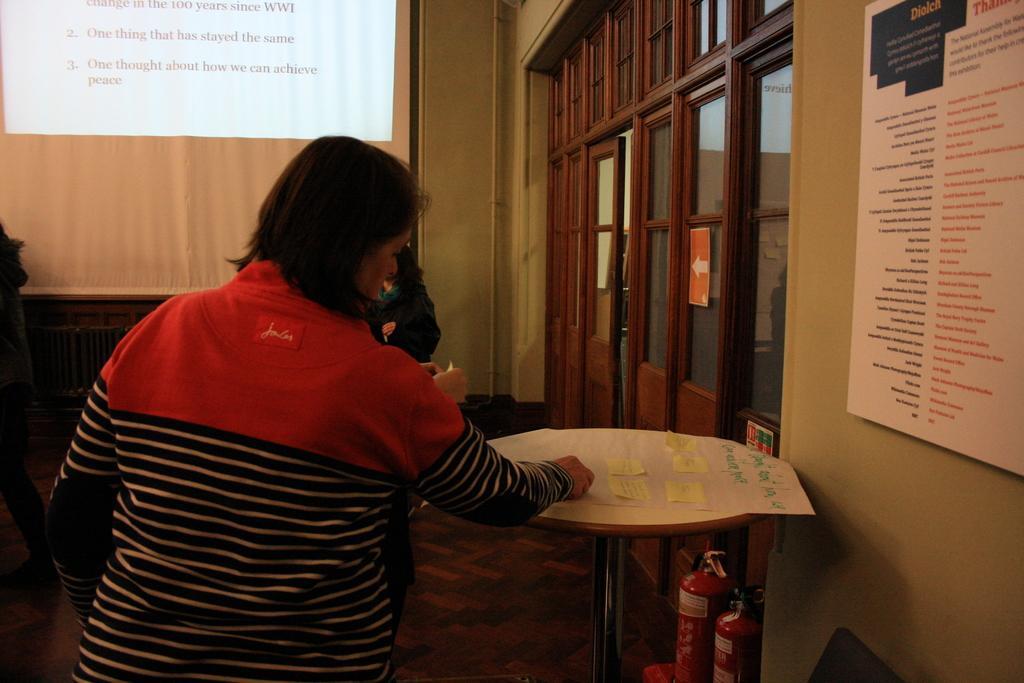How would you summarize this image in a sentence or two? In this there is a lady at the left side of the image resting her hand on the table which is placed at the center of the image, there is a projector screen at the left side of the image and there is a door at the right side of the image, there is a board which is hanged on the wall at the right side of the image and there are two cylinders which are placed under the table. 